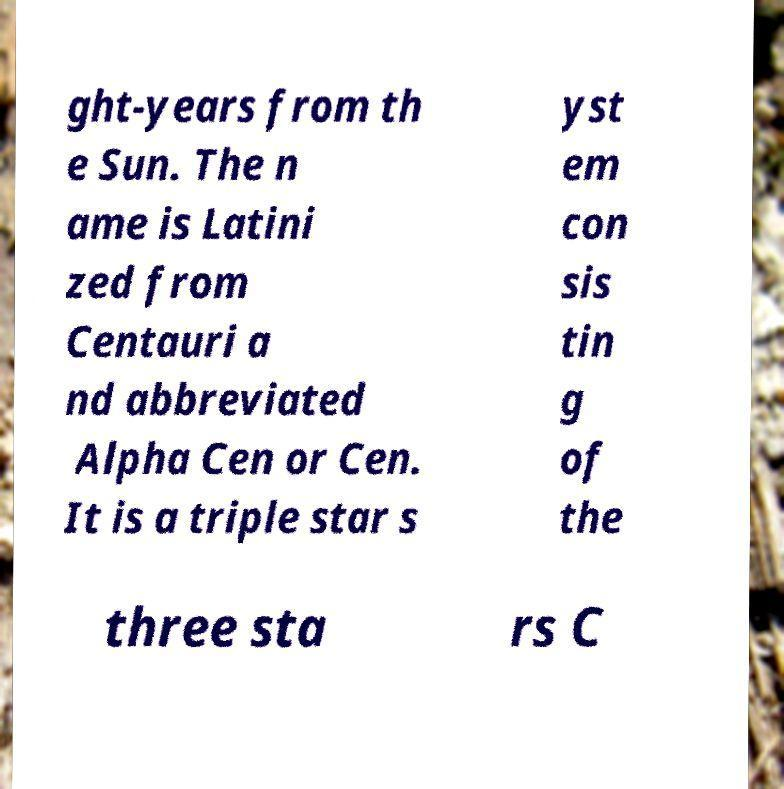Could you assist in decoding the text presented in this image and type it out clearly? ght-years from th e Sun. The n ame is Latini zed from Centauri a nd abbreviated Alpha Cen or Cen. It is a triple star s yst em con sis tin g of the three sta rs C 